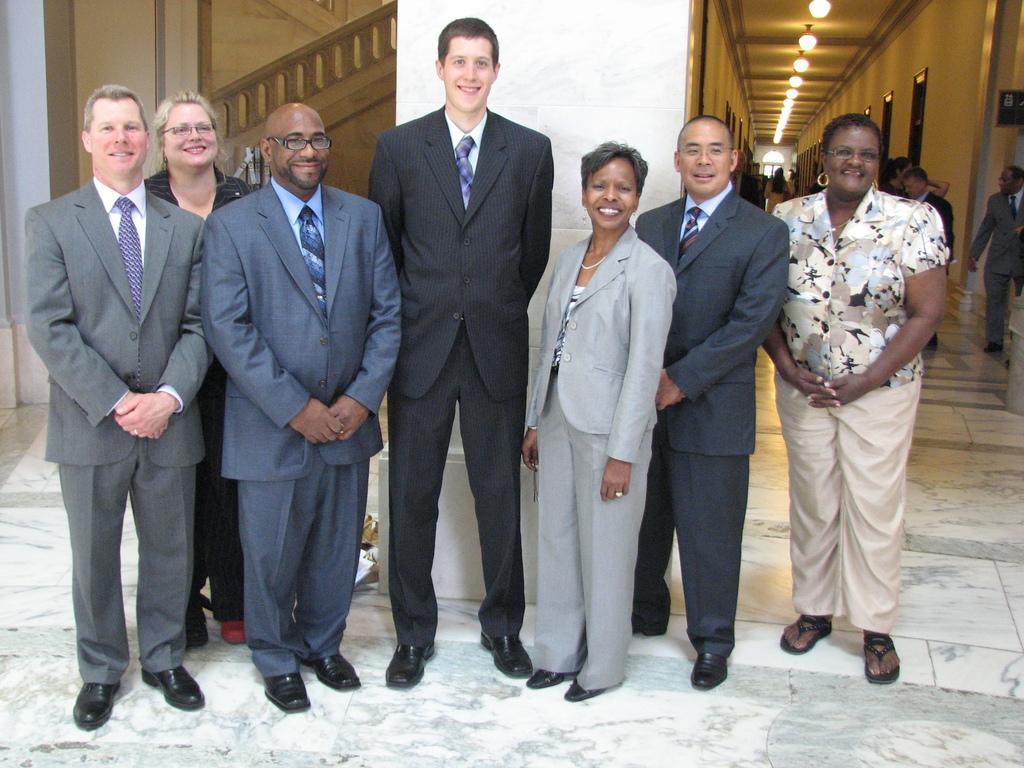Describe this image in one or two sentences. Here we can see few persons are standing on the floor and they are smiling. In the background we can see a wall, lights, doors, and roof. 